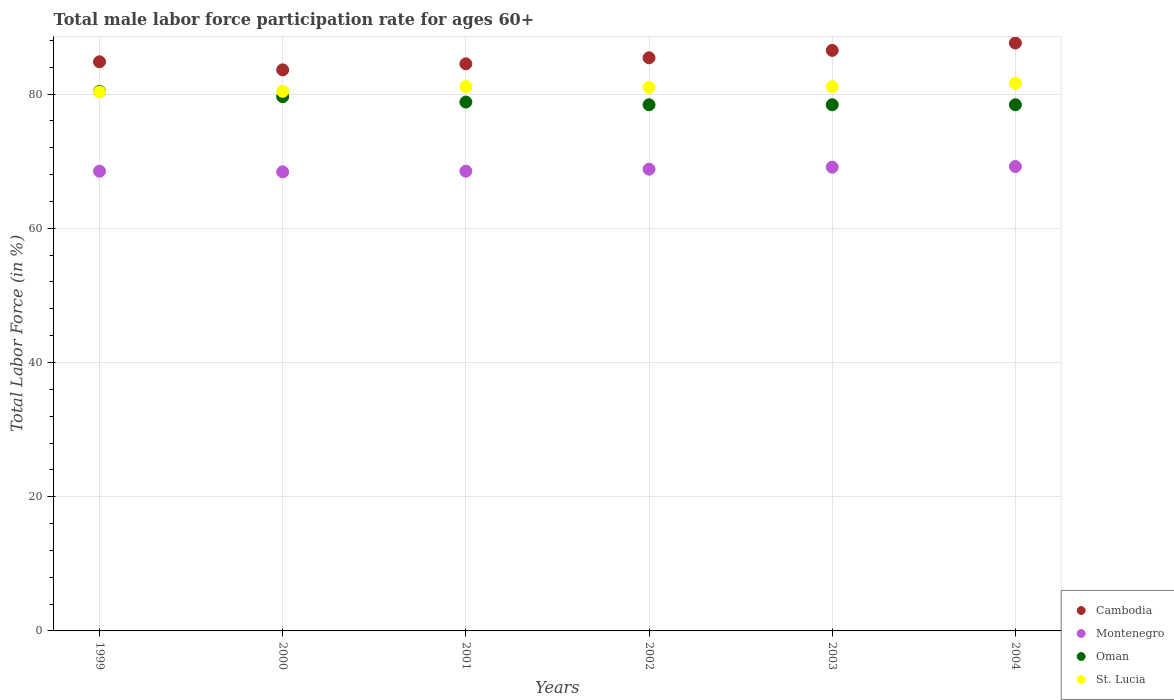Is the number of dotlines equal to the number of legend labels?
Provide a short and direct response. Yes. What is the male labor force participation rate in Oman in 2002?
Your answer should be compact. 78.4. Across all years, what is the maximum male labor force participation rate in Oman?
Keep it short and to the point. 80.4. Across all years, what is the minimum male labor force participation rate in Oman?
Offer a terse response. 78.4. In which year was the male labor force participation rate in St. Lucia maximum?
Give a very brief answer. 2004. What is the total male labor force participation rate in Cambodia in the graph?
Provide a short and direct response. 512.4. What is the difference between the male labor force participation rate in Cambodia in 2003 and the male labor force participation rate in Oman in 1999?
Make the answer very short. 6.1. What is the average male labor force participation rate in Cambodia per year?
Your answer should be very brief. 85.4. In the year 2001, what is the difference between the male labor force participation rate in Oman and male labor force participation rate in St. Lucia?
Your answer should be compact. -2.3. What is the ratio of the male labor force participation rate in St. Lucia in 2000 to that in 2004?
Provide a succinct answer. 0.99. Is the male labor force participation rate in Cambodia in 1999 less than that in 2001?
Your answer should be very brief. No. What is the difference between the highest and the second highest male labor force participation rate in Cambodia?
Provide a succinct answer. 1.1. What is the difference between the highest and the lowest male labor force participation rate in St. Lucia?
Keep it short and to the point. 1.3. In how many years, is the male labor force participation rate in St. Lucia greater than the average male labor force participation rate in St. Lucia taken over all years?
Make the answer very short. 4. Is it the case that in every year, the sum of the male labor force participation rate in Montenegro and male labor force participation rate in Cambodia  is greater than the sum of male labor force participation rate in Oman and male labor force participation rate in St. Lucia?
Provide a short and direct response. No. Does the male labor force participation rate in Oman monotonically increase over the years?
Offer a terse response. No. How many years are there in the graph?
Your answer should be compact. 6. What is the difference between two consecutive major ticks on the Y-axis?
Offer a terse response. 20. Are the values on the major ticks of Y-axis written in scientific E-notation?
Provide a short and direct response. No. Does the graph contain any zero values?
Your answer should be compact. No. Does the graph contain grids?
Offer a very short reply. Yes. How many legend labels are there?
Give a very brief answer. 4. What is the title of the graph?
Your response must be concise. Total male labor force participation rate for ages 60+. What is the label or title of the X-axis?
Make the answer very short. Years. What is the Total Labor Force (in %) of Cambodia in 1999?
Ensure brevity in your answer.  84.8. What is the Total Labor Force (in %) in Montenegro in 1999?
Give a very brief answer. 68.5. What is the Total Labor Force (in %) in Oman in 1999?
Offer a very short reply. 80.4. What is the Total Labor Force (in %) of St. Lucia in 1999?
Make the answer very short. 80.3. What is the Total Labor Force (in %) in Cambodia in 2000?
Offer a very short reply. 83.6. What is the Total Labor Force (in %) of Montenegro in 2000?
Your response must be concise. 68.4. What is the Total Labor Force (in %) of Oman in 2000?
Give a very brief answer. 79.6. What is the Total Labor Force (in %) of St. Lucia in 2000?
Offer a very short reply. 80.4. What is the Total Labor Force (in %) of Cambodia in 2001?
Your answer should be very brief. 84.5. What is the Total Labor Force (in %) of Montenegro in 2001?
Give a very brief answer. 68.5. What is the Total Labor Force (in %) in Oman in 2001?
Make the answer very short. 78.8. What is the Total Labor Force (in %) in St. Lucia in 2001?
Offer a very short reply. 81.1. What is the Total Labor Force (in %) in Cambodia in 2002?
Your answer should be very brief. 85.4. What is the Total Labor Force (in %) in Montenegro in 2002?
Keep it short and to the point. 68.8. What is the Total Labor Force (in %) in Oman in 2002?
Offer a very short reply. 78.4. What is the Total Labor Force (in %) of St. Lucia in 2002?
Ensure brevity in your answer.  81. What is the Total Labor Force (in %) in Cambodia in 2003?
Provide a succinct answer. 86.5. What is the Total Labor Force (in %) of Montenegro in 2003?
Keep it short and to the point. 69.1. What is the Total Labor Force (in %) in Oman in 2003?
Provide a short and direct response. 78.4. What is the Total Labor Force (in %) of St. Lucia in 2003?
Offer a very short reply. 81.1. What is the Total Labor Force (in %) in Cambodia in 2004?
Ensure brevity in your answer.  87.6. What is the Total Labor Force (in %) in Montenegro in 2004?
Give a very brief answer. 69.2. What is the Total Labor Force (in %) of Oman in 2004?
Give a very brief answer. 78.4. What is the Total Labor Force (in %) of St. Lucia in 2004?
Give a very brief answer. 81.6. Across all years, what is the maximum Total Labor Force (in %) of Cambodia?
Provide a short and direct response. 87.6. Across all years, what is the maximum Total Labor Force (in %) of Montenegro?
Keep it short and to the point. 69.2. Across all years, what is the maximum Total Labor Force (in %) in Oman?
Your answer should be very brief. 80.4. Across all years, what is the maximum Total Labor Force (in %) of St. Lucia?
Give a very brief answer. 81.6. Across all years, what is the minimum Total Labor Force (in %) in Cambodia?
Give a very brief answer. 83.6. Across all years, what is the minimum Total Labor Force (in %) in Montenegro?
Provide a short and direct response. 68.4. Across all years, what is the minimum Total Labor Force (in %) of Oman?
Ensure brevity in your answer.  78.4. Across all years, what is the minimum Total Labor Force (in %) of St. Lucia?
Your response must be concise. 80.3. What is the total Total Labor Force (in %) in Cambodia in the graph?
Make the answer very short. 512.4. What is the total Total Labor Force (in %) of Montenegro in the graph?
Keep it short and to the point. 412.5. What is the total Total Labor Force (in %) in Oman in the graph?
Give a very brief answer. 474. What is the total Total Labor Force (in %) in St. Lucia in the graph?
Make the answer very short. 485.5. What is the difference between the Total Labor Force (in %) of Cambodia in 1999 and that in 2000?
Your answer should be compact. 1.2. What is the difference between the Total Labor Force (in %) of Montenegro in 1999 and that in 2000?
Make the answer very short. 0.1. What is the difference between the Total Labor Force (in %) of St. Lucia in 1999 and that in 2000?
Make the answer very short. -0.1. What is the difference between the Total Labor Force (in %) in Cambodia in 1999 and that in 2001?
Make the answer very short. 0.3. What is the difference between the Total Labor Force (in %) in Oman in 1999 and that in 2002?
Provide a short and direct response. 2. What is the difference between the Total Labor Force (in %) of St. Lucia in 1999 and that in 2002?
Make the answer very short. -0.7. What is the difference between the Total Labor Force (in %) of Oman in 1999 and that in 2003?
Offer a very short reply. 2. What is the difference between the Total Labor Force (in %) of St. Lucia in 1999 and that in 2003?
Provide a short and direct response. -0.8. What is the difference between the Total Labor Force (in %) in Montenegro in 1999 and that in 2004?
Your response must be concise. -0.7. What is the difference between the Total Labor Force (in %) in Montenegro in 2000 and that in 2002?
Provide a short and direct response. -0.4. What is the difference between the Total Labor Force (in %) of St. Lucia in 2000 and that in 2002?
Keep it short and to the point. -0.6. What is the difference between the Total Labor Force (in %) of Montenegro in 2000 and that in 2003?
Provide a succinct answer. -0.7. What is the difference between the Total Labor Force (in %) of Oman in 2000 and that in 2003?
Provide a short and direct response. 1.2. What is the difference between the Total Labor Force (in %) in Cambodia in 2000 and that in 2004?
Provide a succinct answer. -4. What is the difference between the Total Labor Force (in %) in Oman in 2000 and that in 2004?
Make the answer very short. 1.2. What is the difference between the Total Labor Force (in %) in Oman in 2001 and that in 2002?
Provide a succinct answer. 0.4. What is the difference between the Total Labor Force (in %) of St. Lucia in 2001 and that in 2002?
Offer a very short reply. 0.1. What is the difference between the Total Labor Force (in %) in Cambodia in 2001 and that in 2003?
Give a very brief answer. -2. What is the difference between the Total Labor Force (in %) in Montenegro in 2001 and that in 2003?
Keep it short and to the point. -0.6. What is the difference between the Total Labor Force (in %) of Cambodia in 2001 and that in 2004?
Offer a terse response. -3.1. What is the difference between the Total Labor Force (in %) in Montenegro in 2001 and that in 2004?
Ensure brevity in your answer.  -0.7. What is the difference between the Total Labor Force (in %) of Oman in 2001 and that in 2004?
Keep it short and to the point. 0.4. What is the difference between the Total Labor Force (in %) of Cambodia in 2002 and that in 2003?
Provide a short and direct response. -1.1. What is the difference between the Total Labor Force (in %) in Montenegro in 2002 and that in 2003?
Offer a very short reply. -0.3. What is the difference between the Total Labor Force (in %) of St. Lucia in 2002 and that in 2003?
Your answer should be very brief. -0.1. What is the difference between the Total Labor Force (in %) in Cambodia in 2002 and that in 2004?
Keep it short and to the point. -2.2. What is the difference between the Total Labor Force (in %) in Montenegro in 2002 and that in 2004?
Your answer should be very brief. -0.4. What is the difference between the Total Labor Force (in %) of Oman in 2002 and that in 2004?
Your response must be concise. 0. What is the difference between the Total Labor Force (in %) in Cambodia in 2003 and that in 2004?
Your answer should be very brief. -1.1. What is the difference between the Total Labor Force (in %) in Montenegro in 2003 and that in 2004?
Make the answer very short. -0.1. What is the difference between the Total Labor Force (in %) of Cambodia in 1999 and the Total Labor Force (in %) of St. Lucia in 2000?
Your answer should be compact. 4.4. What is the difference between the Total Labor Force (in %) in Montenegro in 1999 and the Total Labor Force (in %) in St. Lucia in 2000?
Provide a succinct answer. -11.9. What is the difference between the Total Labor Force (in %) in Oman in 1999 and the Total Labor Force (in %) in St. Lucia in 2000?
Your response must be concise. 0. What is the difference between the Total Labor Force (in %) of Cambodia in 1999 and the Total Labor Force (in %) of Montenegro in 2001?
Provide a succinct answer. 16.3. What is the difference between the Total Labor Force (in %) of Cambodia in 1999 and the Total Labor Force (in %) of Oman in 2002?
Offer a terse response. 6.4. What is the difference between the Total Labor Force (in %) of Montenegro in 1999 and the Total Labor Force (in %) of St. Lucia in 2002?
Provide a short and direct response. -12.5. What is the difference between the Total Labor Force (in %) of Cambodia in 1999 and the Total Labor Force (in %) of St. Lucia in 2003?
Ensure brevity in your answer.  3.7. What is the difference between the Total Labor Force (in %) of Montenegro in 1999 and the Total Labor Force (in %) of St. Lucia in 2003?
Your answer should be compact. -12.6. What is the difference between the Total Labor Force (in %) of Oman in 1999 and the Total Labor Force (in %) of St. Lucia in 2003?
Give a very brief answer. -0.7. What is the difference between the Total Labor Force (in %) in Cambodia in 1999 and the Total Labor Force (in %) in Montenegro in 2004?
Offer a very short reply. 15.6. What is the difference between the Total Labor Force (in %) of Cambodia in 1999 and the Total Labor Force (in %) of Oman in 2004?
Provide a short and direct response. 6.4. What is the difference between the Total Labor Force (in %) in Cambodia in 2000 and the Total Labor Force (in %) in St. Lucia in 2001?
Keep it short and to the point. 2.5. What is the difference between the Total Labor Force (in %) in Montenegro in 2000 and the Total Labor Force (in %) in St. Lucia in 2001?
Make the answer very short. -12.7. What is the difference between the Total Labor Force (in %) in Oman in 2000 and the Total Labor Force (in %) in St. Lucia in 2001?
Keep it short and to the point. -1.5. What is the difference between the Total Labor Force (in %) of Cambodia in 2000 and the Total Labor Force (in %) of Montenegro in 2002?
Your answer should be very brief. 14.8. What is the difference between the Total Labor Force (in %) in Cambodia in 2000 and the Total Labor Force (in %) in Oman in 2002?
Offer a terse response. 5.2. What is the difference between the Total Labor Force (in %) of Cambodia in 2000 and the Total Labor Force (in %) of St. Lucia in 2002?
Offer a very short reply. 2.6. What is the difference between the Total Labor Force (in %) in Montenegro in 2000 and the Total Labor Force (in %) in St. Lucia in 2002?
Your response must be concise. -12.6. What is the difference between the Total Labor Force (in %) of Oman in 2000 and the Total Labor Force (in %) of St. Lucia in 2002?
Offer a very short reply. -1.4. What is the difference between the Total Labor Force (in %) in Montenegro in 2000 and the Total Labor Force (in %) in Oman in 2003?
Your answer should be very brief. -10. What is the difference between the Total Labor Force (in %) of Montenegro in 2000 and the Total Labor Force (in %) of St. Lucia in 2003?
Your response must be concise. -12.7. What is the difference between the Total Labor Force (in %) in Oman in 2000 and the Total Labor Force (in %) in St. Lucia in 2003?
Your answer should be compact. -1.5. What is the difference between the Total Labor Force (in %) of Cambodia in 2000 and the Total Labor Force (in %) of Montenegro in 2004?
Your answer should be very brief. 14.4. What is the difference between the Total Labor Force (in %) of Cambodia in 2000 and the Total Labor Force (in %) of Oman in 2004?
Ensure brevity in your answer.  5.2. What is the difference between the Total Labor Force (in %) of Montenegro in 2000 and the Total Labor Force (in %) of Oman in 2004?
Provide a succinct answer. -10. What is the difference between the Total Labor Force (in %) of Cambodia in 2001 and the Total Labor Force (in %) of Oman in 2002?
Keep it short and to the point. 6.1. What is the difference between the Total Labor Force (in %) of Cambodia in 2001 and the Total Labor Force (in %) of St. Lucia in 2002?
Offer a very short reply. 3.5. What is the difference between the Total Labor Force (in %) of Montenegro in 2001 and the Total Labor Force (in %) of Oman in 2002?
Make the answer very short. -9.9. What is the difference between the Total Labor Force (in %) of Montenegro in 2001 and the Total Labor Force (in %) of St. Lucia in 2002?
Ensure brevity in your answer.  -12.5. What is the difference between the Total Labor Force (in %) of Oman in 2001 and the Total Labor Force (in %) of St. Lucia in 2002?
Provide a short and direct response. -2.2. What is the difference between the Total Labor Force (in %) in Cambodia in 2001 and the Total Labor Force (in %) in Montenegro in 2003?
Make the answer very short. 15.4. What is the difference between the Total Labor Force (in %) of Montenegro in 2001 and the Total Labor Force (in %) of Oman in 2003?
Your answer should be very brief. -9.9. What is the difference between the Total Labor Force (in %) of Cambodia in 2001 and the Total Labor Force (in %) of Oman in 2004?
Keep it short and to the point. 6.1. What is the difference between the Total Labor Force (in %) of Montenegro in 2001 and the Total Labor Force (in %) of Oman in 2004?
Offer a very short reply. -9.9. What is the difference between the Total Labor Force (in %) of Cambodia in 2002 and the Total Labor Force (in %) of Montenegro in 2003?
Keep it short and to the point. 16.3. What is the difference between the Total Labor Force (in %) of Cambodia in 2002 and the Total Labor Force (in %) of Oman in 2003?
Give a very brief answer. 7. What is the difference between the Total Labor Force (in %) in Montenegro in 2002 and the Total Labor Force (in %) in Oman in 2003?
Keep it short and to the point. -9.6. What is the difference between the Total Labor Force (in %) in Oman in 2002 and the Total Labor Force (in %) in St. Lucia in 2003?
Your answer should be compact. -2.7. What is the difference between the Total Labor Force (in %) of Montenegro in 2002 and the Total Labor Force (in %) of Oman in 2004?
Ensure brevity in your answer.  -9.6. What is the difference between the Total Labor Force (in %) of Montenegro in 2002 and the Total Labor Force (in %) of St. Lucia in 2004?
Ensure brevity in your answer.  -12.8. What is the difference between the Total Labor Force (in %) of Cambodia in 2003 and the Total Labor Force (in %) of Montenegro in 2004?
Your answer should be compact. 17.3. What is the difference between the Total Labor Force (in %) in Cambodia in 2003 and the Total Labor Force (in %) in Oman in 2004?
Your answer should be very brief. 8.1. What is the average Total Labor Force (in %) in Cambodia per year?
Offer a terse response. 85.4. What is the average Total Labor Force (in %) in Montenegro per year?
Provide a short and direct response. 68.75. What is the average Total Labor Force (in %) of Oman per year?
Make the answer very short. 79. What is the average Total Labor Force (in %) in St. Lucia per year?
Offer a very short reply. 80.92. In the year 1999, what is the difference between the Total Labor Force (in %) of Montenegro and Total Labor Force (in %) of St. Lucia?
Provide a short and direct response. -11.8. In the year 1999, what is the difference between the Total Labor Force (in %) in Oman and Total Labor Force (in %) in St. Lucia?
Make the answer very short. 0.1. In the year 2000, what is the difference between the Total Labor Force (in %) in Cambodia and Total Labor Force (in %) in Montenegro?
Give a very brief answer. 15.2. In the year 2000, what is the difference between the Total Labor Force (in %) in Montenegro and Total Labor Force (in %) in Oman?
Keep it short and to the point. -11.2. In the year 2000, what is the difference between the Total Labor Force (in %) in Montenegro and Total Labor Force (in %) in St. Lucia?
Keep it short and to the point. -12. In the year 2001, what is the difference between the Total Labor Force (in %) in Cambodia and Total Labor Force (in %) in Oman?
Make the answer very short. 5.7. In the year 2001, what is the difference between the Total Labor Force (in %) in Cambodia and Total Labor Force (in %) in St. Lucia?
Keep it short and to the point. 3.4. In the year 2001, what is the difference between the Total Labor Force (in %) in Montenegro and Total Labor Force (in %) in St. Lucia?
Ensure brevity in your answer.  -12.6. In the year 2001, what is the difference between the Total Labor Force (in %) in Oman and Total Labor Force (in %) in St. Lucia?
Your response must be concise. -2.3. In the year 2002, what is the difference between the Total Labor Force (in %) in Cambodia and Total Labor Force (in %) in Montenegro?
Ensure brevity in your answer.  16.6. In the year 2002, what is the difference between the Total Labor Force (in %) in Cambodia and Total Labor Force (in %) in Oman?
Give a very brief answer. 7. In the year 2002, what is the difference between the Total Labor Force (in %) in Cambodia and Total Labor Force (in %) in St. Lucia?
Offer a terse response. 4.4. In the year 2002, what is the difference between the Total Labor Force (in %) of Oman and Total Labor Force (in %) of St. Lucia?
Provide a short and direct response. -2.6. In the year 2003, what is the difference between the Total Labor Force (in %) in Cambodia and Total Labor Force (in %) in Montenegro?
Ensure brevity in your answer.  17.4. In the year 2003, what is the difference between the Total Labor Force (in %) of Cambodia and Total Labor Force (in %) of Oman?
Your answer should be very brief. 8.1. In the year 2003, what is the difference between the Total Labor Force (in %) of Cambodia and Total Labor Force (in %) of St. Lucia?
Offer a terse response. 5.4. In the year 2003, what is the difference between the Total Labor Force (in %) in Montenegro and Total Labor Force (in %) in St. Lucia?
Your response must be concise. -12. In the year 2004, what is the difference between the Total Labor Force (in %) of Cambodia and Total Labor Force (in %) of St. Lucia?
Your answer should be very brief. 6. In the year 2004, what is the difference between the Total Labor Force (in %) of Montenegro and Total Labor Force (in %) of Oman?
Your answer should be compact. -9.2. What is the ratio of the Total Labor Force (in %) in Cambodia in 1999 to that in 2000?
Keep it short and to the point. 1.01. What is the ratio of the Total Labor Force (in %) in Montenegro in 1999 to that in 2000?
Offer a very short reply. 1. What is the ratio of the Total Labor Force (in %) of Oman in 1999 to that in 2000?
Offer a terse response. 1.01. What is the ratio of the Total Labor Force (in %) in Cambodia in 1999 to that in 2001?
Offer a very short reply. 1. What is the ratio of the Total Labor Force (in %) in Montenegro in 1999 to that in 2001?
Your answer should be compact. 1. What is the ratio of the Total Labor Force (in %) in Oman in 1999 to that in 2001?
Provide a succinct answer. 1.02. What is the ratio of the Total Labor Force (in %) of St. Lucia in 1999 to that in 2001?
Make the answer very short. 0.99. What is the ratio of the Total Labor Force (in %) in Montenegro in 1999 to that in 2002?
Offer a very short reply. 1. What is the ratio of the Total Labor Force (in %) in Oman in 1999 to that in 2002?
Your answer should be compact. 1.03. What is the ratio of the Total Labor Force (in %) in Cambodia in 1999 to that in 2003?
Provide a succinct answer. 0.98. What is the ratio of the Total Labor Force (in %) in Oman in 1999 to that in 2003?
Ensure brevity in your answer.  1.03. What is the ratio of the Total Labor Force (in %) of St. Lucia in 1999 to that in 2003?
Your answer should be compact. 0.99. What is the ratio of the Total Labor Force (in %) of Cambodia in 1999 to that in 2004?
Your answer should be compact. 0.97. What is the ratio of the Total Labor Force (in %) in Montenegro in 1999 to that in 2004?
Your answer should be very brief. 0.99. What is the ratio of the Total Labor Force (in %) in Oman in 1999 to that in 2004?
Keep it short and to the point. 1.03. What is the ratio of the Total Labor Force (in %) in St. Lucia in 1999 to that in 2004?
Your answer should be very brief. 0.98. What is the ratio of the Total Labor Force (in %) of Cambodia in 2000 to that in 2001?
Your answer should be very brief. 0.99. What is the ratio of the Total Labor Force (in %) of Oman in 2000 to that in 2001?
Ensure brevity in your answer.  1.01. What is the ratio of the Total Labor Force (in %) of Cambodia in 2000 to that in 2002?
Make the answer very short. 0.98. What is the ratio of the Total Labor Force (in %) in Oman in 2000 to that in 2002?
Your response must be concise. 1.02. What is the ratio of the Total Labor Force (in %) in St. Lucia in 2000 to that in 2002?
Keep it short and to the point. 0.99. What is the ratio of the Total Labor Force (in %) in Cambodia in 2000 to that in 2003?
Offer a very short reply. 0.97. What is the ratio of the Total Labor Force (in %) in Oman in 2000 to that in 2003?
Make the answer very short. 1.02. What is the ratio of the Total Labor Force (in %) in Cambodia in 2000 to that in 2004?
Provide a succinct answer. 0.95. What is the ratio of the Total Labor Force (in %) in Montenegro in 2000 to that in 2004?
Make the answer very short. 0.99. What is the ratio of the Total Labor Force (in %) of Oman in 2000 to that in 2004?
Your answer should be very brief. 1.02. What is the ratio of the Total Labor Force (in %) of St. Lucia in 2000 to that in 2004?
Give a very brief answer. 0.99. What is the ratio of the Total Labor Force (in %) in Cambodia in 2001 to that in 2002?
Your response must be concise. 0.99. What is the ratio of the Total Labor Force (in %) of Montenegro in 2001 to that in 2002?
Make the answer very short. 1. What is the ratio of the Total Labor Force (in %) in Oman in 2001 to that in 2002?
Offer a very short reply. 1.01. What is the ratio of the Total Labor Force (in %) in St. Lucia in 2001 to that in 2002?
Ensure brevity in your answer.  1. What is the ratio of the Total Labor Force (in %) in Cambodia in 2001 to that in 2003?
Your answer should be very brief. 0.98. What is the ratio of the Total Labor Force (in %) in Montenegro in 2001 to that in 2003?
Your answer should be very brief. 0.99. What is the ratio of the Total Labor Force (in %) of Oman in 2001 to that in 2003?
Provide a succinct answer. 1.01. What is the ratio of the Total Labor Force (in %) of St. Lucia in 2001 to that in 2003?
Ensure brevity in your answer.  1. What is the ratio of the Total Labor Force (in %) in Cambodia in 2001 to that in 2004?
Offer a very short reply. 0.96. What is the ratio of the Total Labor Force (in %) of Cambodia in 2002 to that in 2003?
Provide a succinct answer. 0.99. What is the ratio of the Total Labor Force (in %) in Montenegro in 2002 to that in 2003?
Offer a very short reply. 1. What is the ratio of the Total Labor Force (in %) in Oman in 2002 to that in 2003?
Offer a terse response. 1. What is the ratio of the Total Labor Force (in %) in Cambodia in 2002 to that in 2004?
Keep it short and to the point. 0.97. What is the ratio of the Total Labor Force (in %) of Montenegro in 2002 to that in 2004?
Your answer should be compact. 0.99. What is the ratio of the Total Labor Force (in %) of Cambodia in 2003 to that in 2004?
Give a very brief answer. 0.99. What is the ratio of the Total Labor Force (in %) in Montenegro in 2003 to that in 2004?
Give a very brief answer. 1. What is the ratio of the Total Labor Force (in %) in Oman in 2003 to that in 2004?
Your answer should be compact. 1. What is the ratio of the Total Labor Force (in %) in St. Lucia in 2003 to that in 2004?
Offer a terse response. 0.99. What is the difference between the highest and the second highest Total Labor Force (in %) in Cambodia?
Your answer should be very brief. 1.1. What is the difference between the highest and the second highest Total Labor Force (in %) in Montenegro?
Provide a succinct answer. 0.1. What is the difference between the highest and the second highest Total Labor Force (in %) in St. Lucia?
Give a very brief answer. 0.5. What is the difference between the highest and the lowest Total Labor Force (in %) in Oman?
Offer a very short reply. 2. What is the difference between the highest and the lowest Total Labor Force (in %) in St. Lucia?
Offer a terse response. 1.3. 